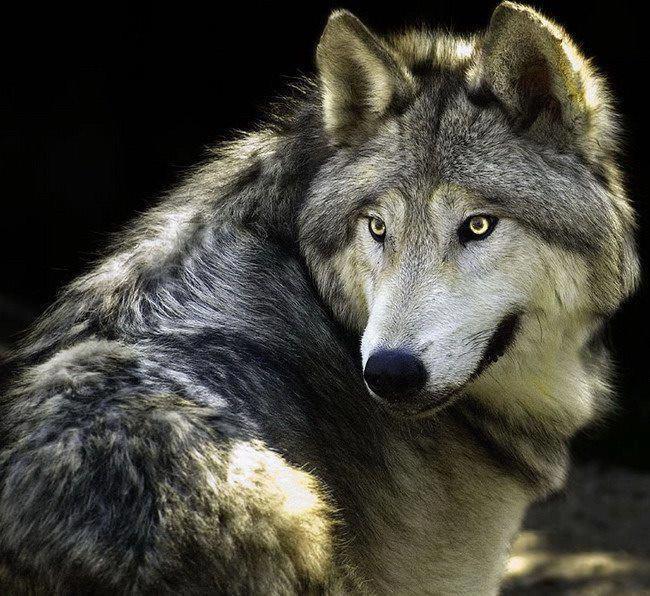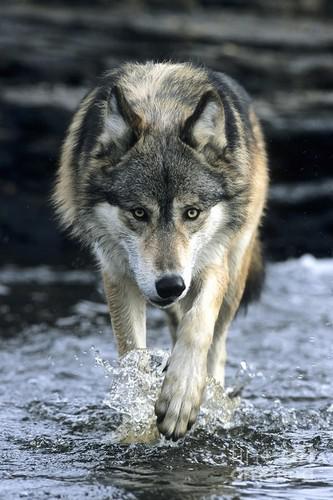The first image is the image on the left, the second image is the image on the right. For the images displayed, is the sentence "wolves are standing with heads lowered toward the camera" factually correct? Answer yes or no. Yes. The first image is the image on the left, the second image is the image on the right. Evaluate the accuracy of this statement regarding the images: "There is one wolf per image, and none of the wolves are showing their teeth.". Is it true? Answer yes or no. Yes. 